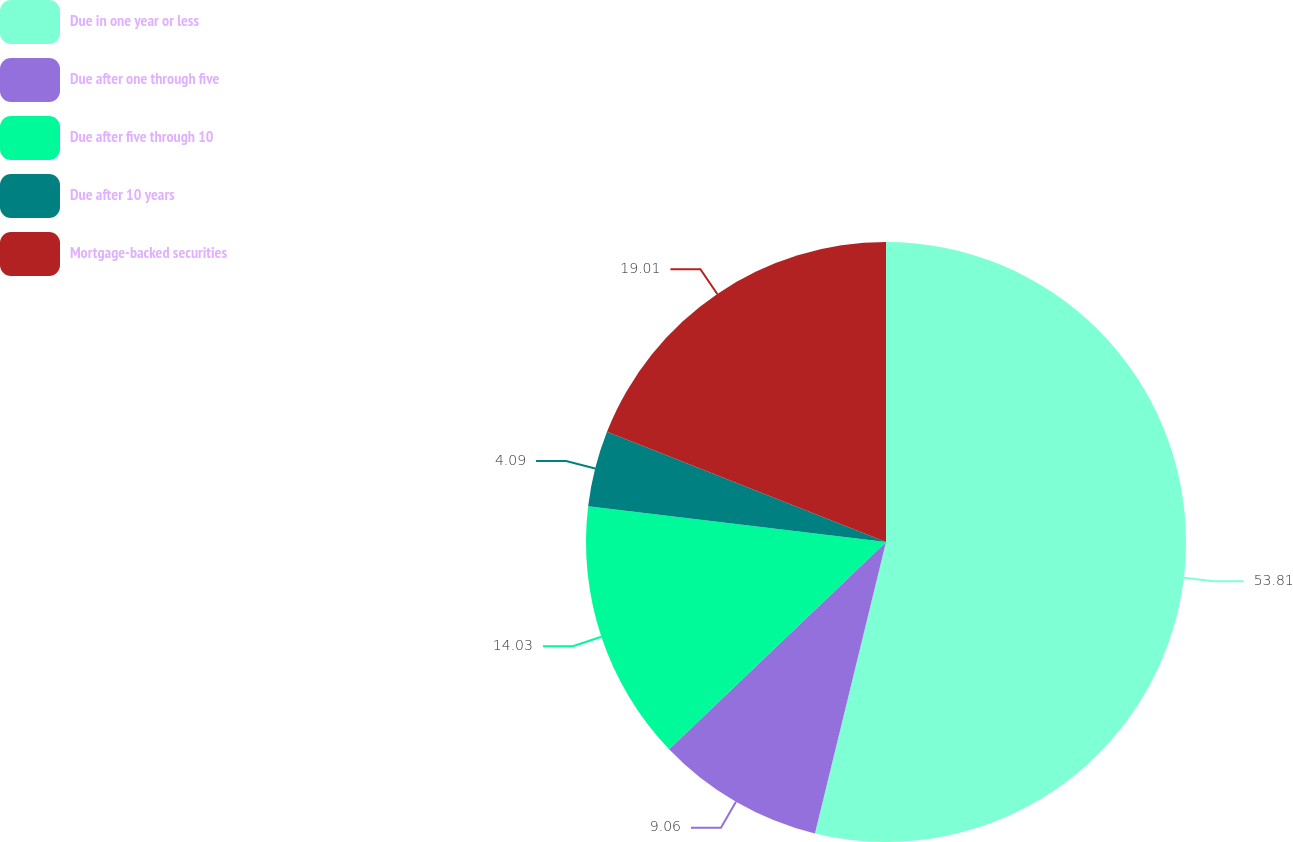Convert chart to OTSL. <chart><loc_0><loc_0><loc_500><loc_500><pie_chart><fcel>Due in one year or less<fcel>Due after one through five<fcel>Due after five through 10<fcel>Due after 10 years<fcel>Mortgage-backed securities<nl><fcel>53.8%<fcel>9.06%<fcel>14.03%<fcel>4.09%<fcel>19.01%<nl></chart> 